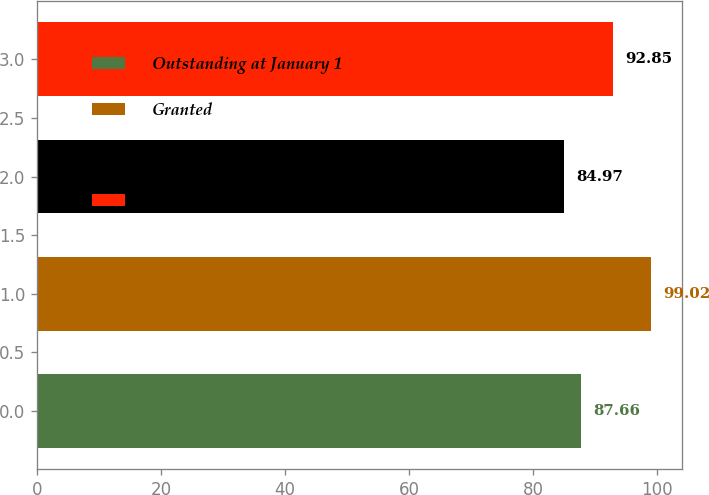Convert chart to OTSL. <chart><loc_0><loc_0><loc_500><loc_500><bar_chart><fcel>Outstanding at January 1<fcel>Granted<fcel>Vested<fcel>Outstanding at December 31<nl><fcel>87.66<fcel>99.02<fcel>84.97<fcel>92.85<nl></chart> 